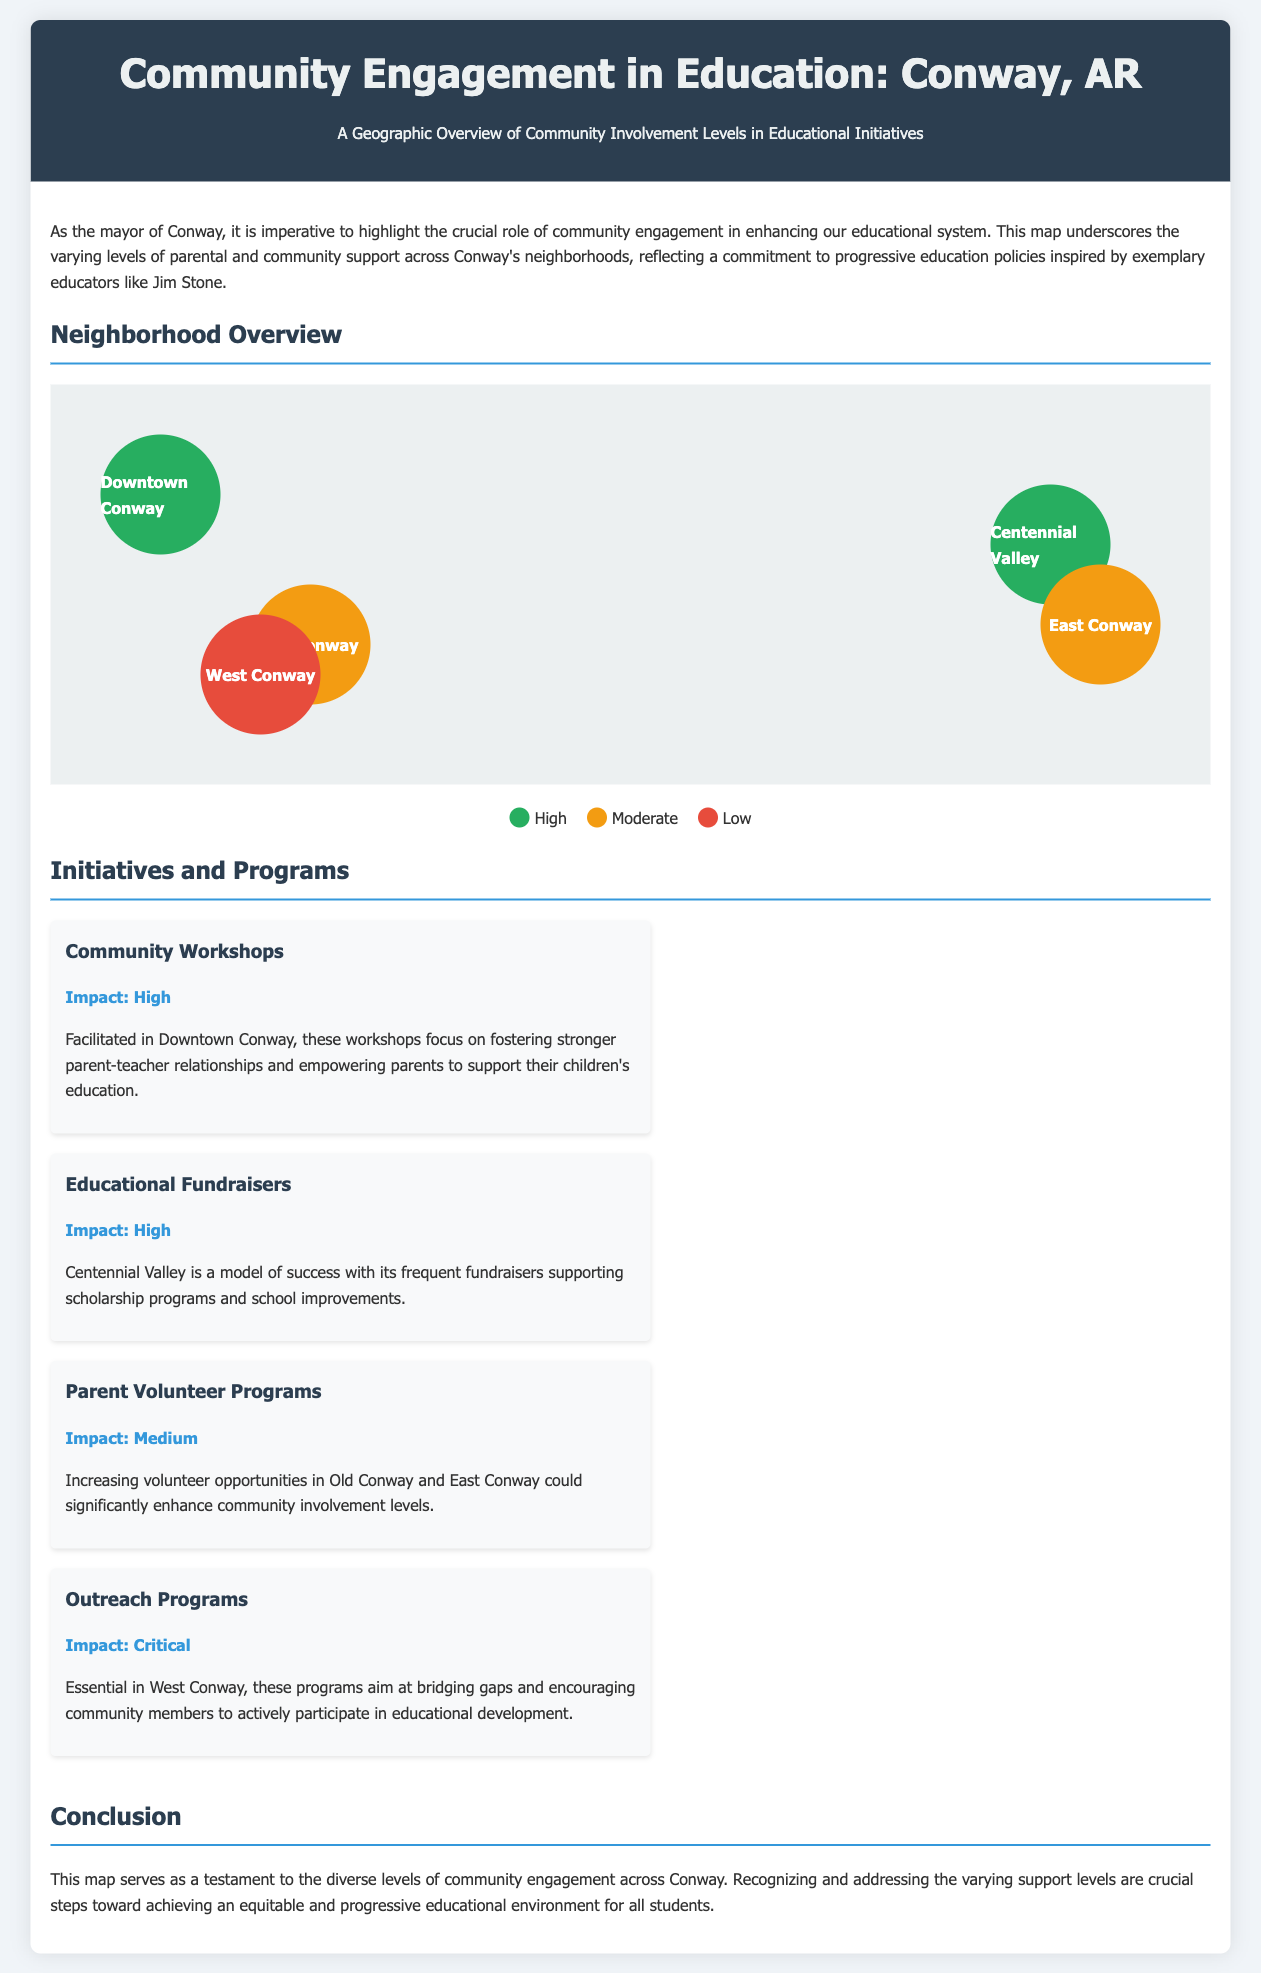What are the neighborhoods highlighted in the map? The document lists Downtown Conway, Old Conway, Centennial Valley, West Conway, and East Conway as the neighborhoods highlighted in the map.
Answer: Downtown Conway, Old Conway, Centennial Valley, West Conway, East Conway Which neighborhood has the highest level of community engagement? Based on the map, Downtown Conway and Centennial Valley both have high levels of community engagement.
Answer: Downtown Conway, Centennial Valley What is the impact of the Community Workshops initiative? The document specifies that the impact of Community Workshops, held in Downtown Conway, is high.
Answer: High What color represents low community support on the map? The legend indicates that the color red represents low community support in the neighborhoods.
Answer: Red Which neighborhood has a critical impact from outreach programs? The document states that outreach programs have a critical impact in West Conway.
Answer: West Conway How many initiatives are mentioned in the document? There are four initiatives mentioned in the document: Community Workshops, Educational Fundraisers, Parent Volunteer Programs, and Outreach Programs.
Answer: Four What demographic does the outreach program primarily target? The outreach program aims to encourage community members to actively participate in educational development, highlighting community involvement.
Answer: Community members Which neighborhood may improve by increasing volunteer opportunities? The document suggests that Old Conway and East Conway could significantly enhance community involvement levels with increased volunteer opportunities.
Answer: Old Conway, East Conway 